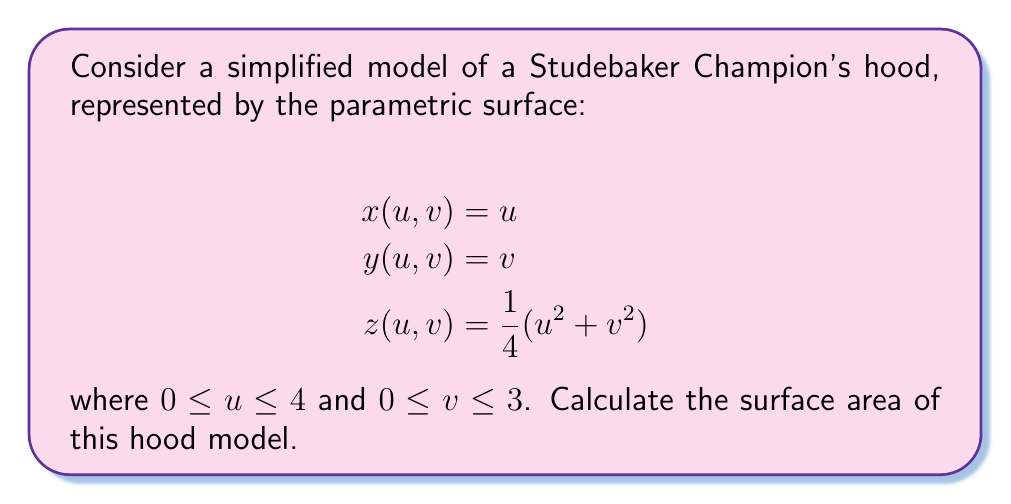Teach me how to tackle this problem. To find the surface area, we need to use the surface area formula for parametric surfaces:

$$A = \iint_D \sqrt{EG - F^2} \,du\,dv$$

where $E = x_u^2 + y_u^2 + z_u^2$, $F = x_ux_v + y_uy_v + z_uz_v$, and $G = x_v^2 + y_v^2 + z_v^2$.

Step 1: Calculate partial derivatives
$$x_u = 1, \quad y_u = 0, \quad z_u = \frac{1}{2}u$$
$$x_v = 0, \quad y_v = 1, \quad z_v = \frac{1}{2}v$$

Step 2: Calculate E, F, and G
$$E = 1^2 + 0^2 + (\frac{1}{2}u)^2 = 1 + \frac{1}{4}u^2$$
$$F = (1)(0) + (0)(1) + (\frac{1}{2}u)(\frac{1}{2}v) = \frac{1}{4}uv$$
$$G = 0^2 + 1^2 + (\frac{1}{2}v)^2 = 1 + \frac{1}{4}v^2$$

Step 3: Calculate $EG - F^2$
$$EG - F^2 = (1 + \frac{1}{4}u^2)(1 + \frac{1}{4}v^2) - (\frac{1}{4}uv)^2$$
$$= 1 + \frac{1}{4}v^2 + \frac{1}{4}u^2 + \frac{1}{16}u^2v^2 - \frac{1}{16}u^2v^2$$
$$= 1 + \frac{1}{4}v^2 + \frac{1}{4}u^2$$

Step 4: Set up the double integral
$$A = \int_0^3 \int_0^4 \sqrt{1 + \frac{1}{4}v^2 + \frac{1}{4}u^2} \,du\,dv$$

Step 5: Evaluate the integral
This integral is complex and doesn't have a simple closed-form solution. We can approximate it numerically using a calculator or computer software.

Using numerical integration, we get:

$$A \approx 14.8259 \text{ square units}$$
Answer: $14.8259 \text{ square units}$ 